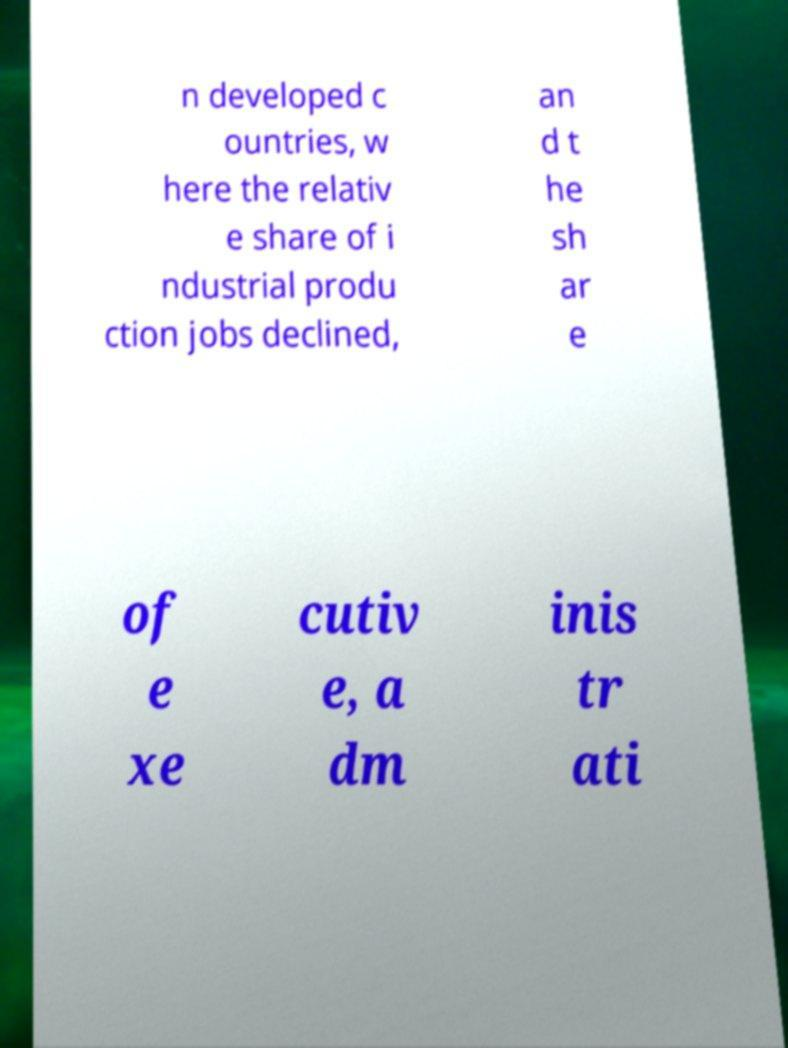For documentation purposes, I need the text within this image transcribed. Could you provide that? n developed c ountries, w here the relativ e share of i ndustrial produ ction jobs declined, an d t he sh ar e of e xe cutiv e, a dm inis tr ati 